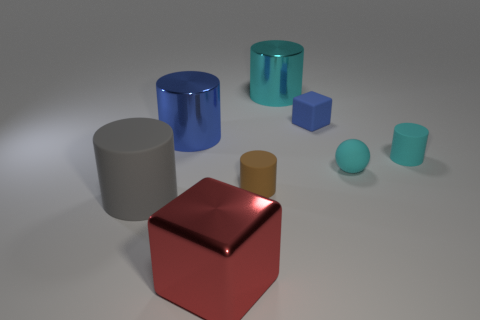The cylinder that is the same color as the small block is what size?
Give a very brief answer. Large. Is there a big red metallic thing that has the same shape as the tiny blue matte thing?
Keep it short and to the point. Yes. Are there an equal number of blue cubes that are in front of the small cyan rubber ball and red rubber balls?
Offer a very short reply. Yes. There is a cube on the left side of the cylinder that is behind the small blue matte cube; what is it made of?
Provide a succinct answer. Metal. There is a tiny brown object; what shape is it?
Provide a short and direct response. Cylinder. Is the number of big matte cylinders that are in front of the large gray cylinder the same as the number of tiny balls that are behind the cyan rubber ball?
Provide a succinct answer. Yes. There is a tiny rubber cylinder that is behind the brown matte thing; is its color the same as the cube that is in front of the brown matte cylinder?
Your answer should be compact. No. Is the number of gray rubber cylinders that are right of the blue cube greater than the number of small cyan cylinders?
Your answer should be very brief. No. There is a big object that is made of the same material as the blue block; what is its shape?
Give a very brief answer. Cylinder. There is a cylinder that is on the right side of the rubber block; does it have the same size as the small matte ball?
Your response must be concise. Yes. 